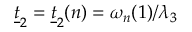<formula> <loc_0><loc_0><loc_500><loc_500>\underline { t } _ { 2 } = \underline { t } _ { 2 } ( n ) = \omega _ { n } ( 1 ) / \lambda _ { 3 }</formula> 